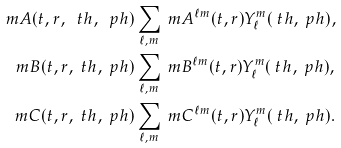<formula> <loc_0><loc_0><loc_500><loc_500>\ m A ( t , r , \ t h , \ p h ) & \sum _ { \ell , m } \ m A ^ { \ell m } ( t , r ) Y _ { \ell } ^ { m } ( \ t h , \ p h ) , \\ \ m B ( t , r , \ t h , \ p h ) & \sum _ { \ell , m } \ m B ^ { \ell m } ( t , r ) Y _ { \ell } ^ { m } ( \ t h , \ p h ) , \\ \ m C ( t , r , \ t h , \ p h ) & \sum _ { \ell , m } \ m C ^ { \ell m } ( t , r ) Y _ { \ell } ^ { m } ( \ t h , \ p h ) .</formula> 